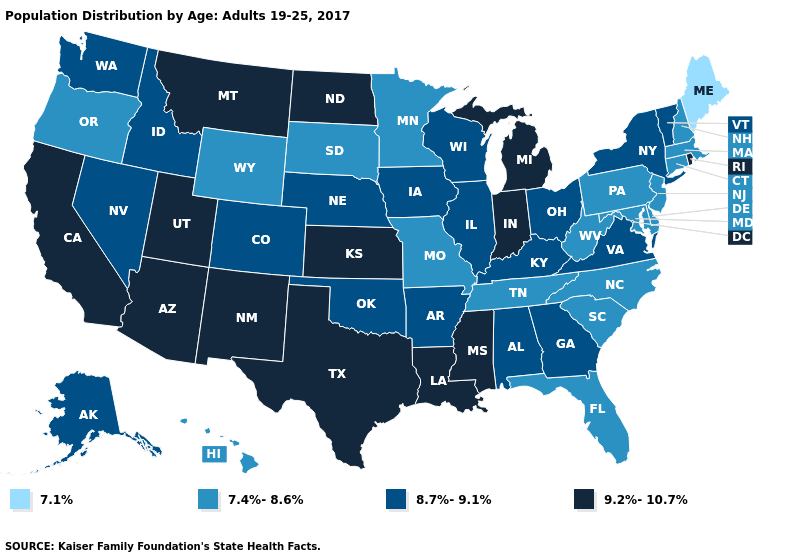Which states have the lowest value in the West?
Short answer required. Hawaii, Oregon, Wyoming. Name the states that have a value in the range 9.2%-10.7%?
Answer briefly. Arizona, California, Indiana, Kansas, Louisiana, Michigan, Mississippi, Montana, New Mexico, North Dakota, Rhode Island, Texas, Utah. What is the value of South Carolina?
Give a very brief answer. 7.4%-8.6%. What is the lowest value in the Northeast?
Quick response, please. 7.1%. What is the value of Maryland?
Quick response, please. 7.4%-8.6%. Is the legend a continuous bar?
Quick response, please. No. What is the highest value in states that border Vermont?
Short answer required. 8.7%-9.1%. Name the states that have a value in the range 8.7%-9.1%?
Quick response, please. Alabama, Alaska, Arkansas, Colorado, Georgia, Idaho, Illinois, Iowa, Kentucky, Nebraska, Nevada, New York, Ohio, Oklahoma, Vermont, Virginia, Washington, Wisconsin. What is the value of Virginia?
Keep it brief. 8.7%-9.1%. Name the states that have a value in the range 7.4%-8.6%?
Keep it brief. Connecticut, Delaware, Florida, Hawaii, Maryland, Massachusetts, Minnesota, Missouri, New Hampshire, New Jersey, North Carolina, Oregon, Pennsylvania, South Carolina, South Dakota, Tennessee, West Virginia, Wyoming. Among the states that border Mississippi , which have the lowest value?
Be succinct. Tennessee. Does Alaska have a lower value than Kansas?
Answer briefly. Yes. Name the states that have a value in the range 8.7%-9.1%?
Concise answer only. Alabama, Alaska, Arkansas, Colorado, Georgia, Idaho, Illinois, Iowa, Kentucky, Nebraska, Nevada, New York, Ohio, Oklahoma, Vermont, Virginia, Washington, Wisconsin. What is the highest value in the USA?
Be succinct. 9.2%-10.7%. What is the highest value in the USA?
Write a very short answer. 9.2%-10.7%. 